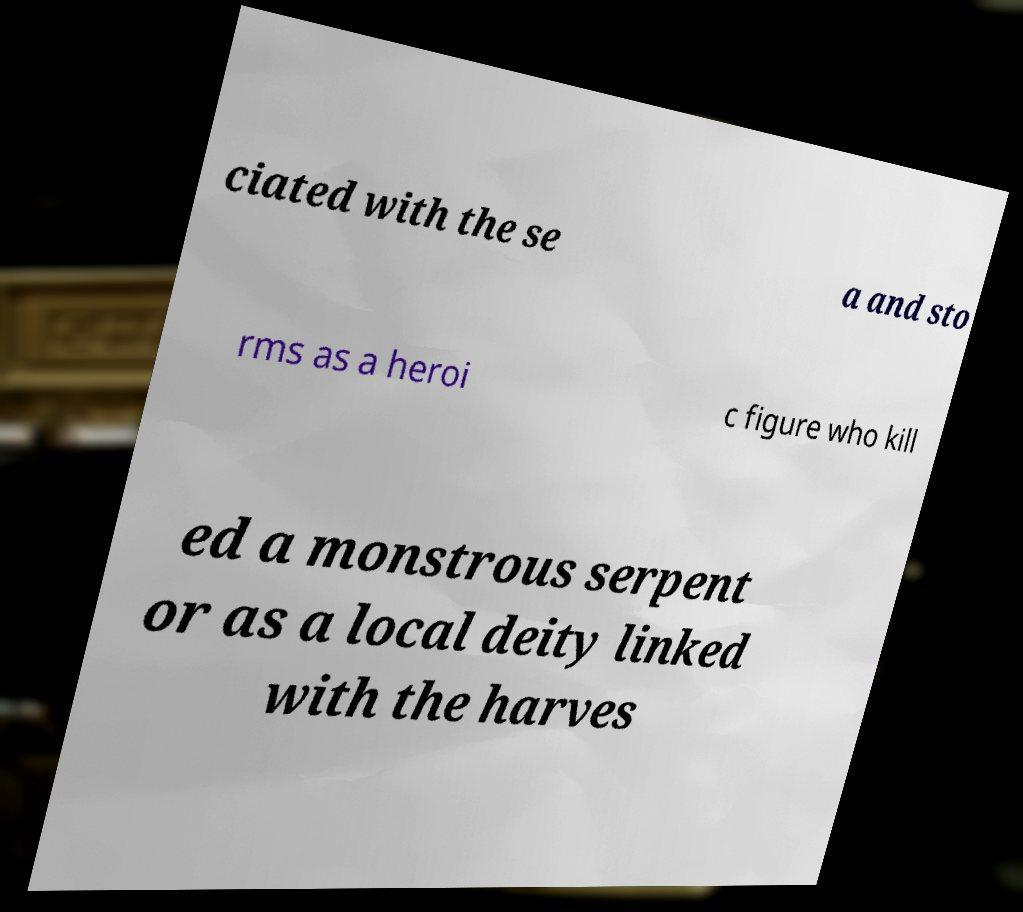There's text embedded in this image that I need extracted. Can you transcribe it verbatim? ciated with the se a and sto rms as a heroi c figure who kill ed a monstrous serpent or as a local deity linked with the harves 